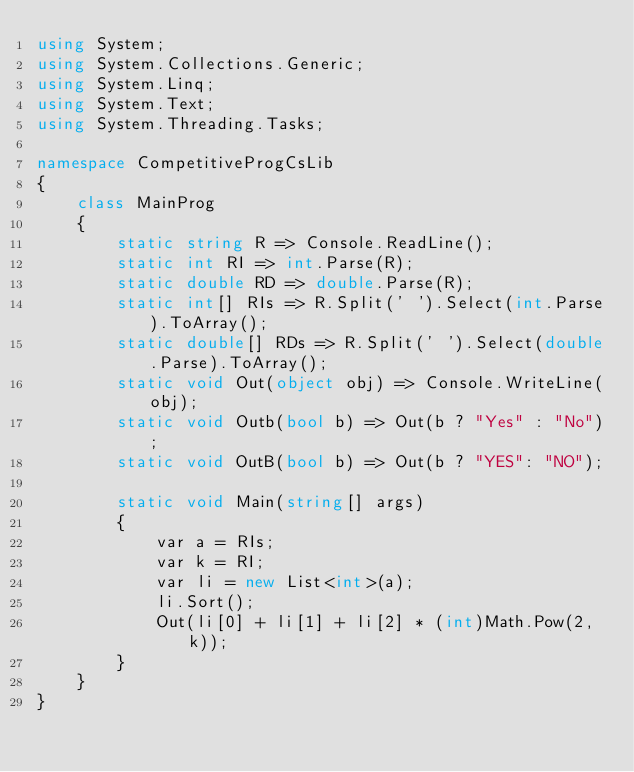<code> <loc_0><loc_0><loc_500><loc_500><_C#_>using System;
using System.Collections.Generic;
using System.Linq;
using System.Text;
using System.Threading.Tasks;

namespace CompetitiveProgCsLib
{
	class MainProg
	{
		static string R => Console.ReadLine();
		static int RI => int.Parse(R);
		static double RD => double.Parse(R);
		static int[] RIs => R.Split(' ').Select(int.Parse).ToArray();
		static double[] RDs => R.Split(' ').Select(double.Parse).ToArray();
		static void Out(object obj) => Console.WriteLine(obj);
		static void Outb(bool b) => Out(b ? "Yes" : "No");
		static void OutB(bool b) => Out(b ? "YES": "NO");

		static void Main(string[] args)
		{
			var a = RIs;
			var k = RI;
			var li = new List<int>(a);
			li.Sort();
			Out(li[0] + li[1] + li[2] * (int)Math.Pow(2, k));
		}
	}
}
</code> 